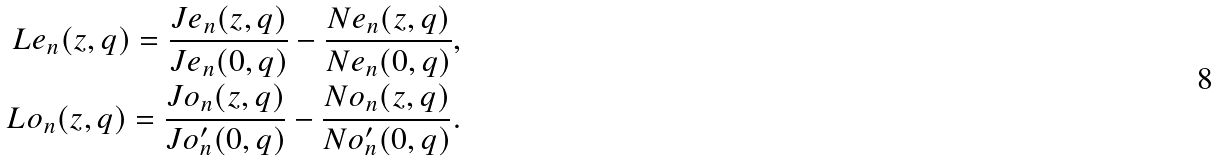<formula> <loc_0><loc_0><loc_500><loc_500>L e _ { n } ( z , q ) = \frac { J e _ { n } ( z , q ) } { J e _ { n } ( 0 , q ) } - \frac { N e _ { n } ( z , q ) } { N e _ { n } ( 0 , q ) } , \\ L o _ { n } ( z , q ) = \frac { J o _ { n } ( z , q ) } { J o _ { n } ^ { \prime } ( 0 , q ) } - \frac { N o _ { n } ( z , q ) } { N o _ { n } ^ { \prime } ( 0 , q ) } .</formula> 